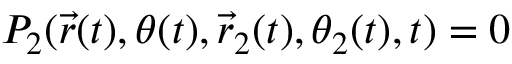Convert formula to latex. <formula><loc_0><loc_0><loc_500><loc_500>P _ { 2 } ( \vec { r } ( t ) , \theta ( t ) , \vec { r } _ { 2 } ( t ) , \theta _ { 2 } ( t ) , t ) = 0</formula> 